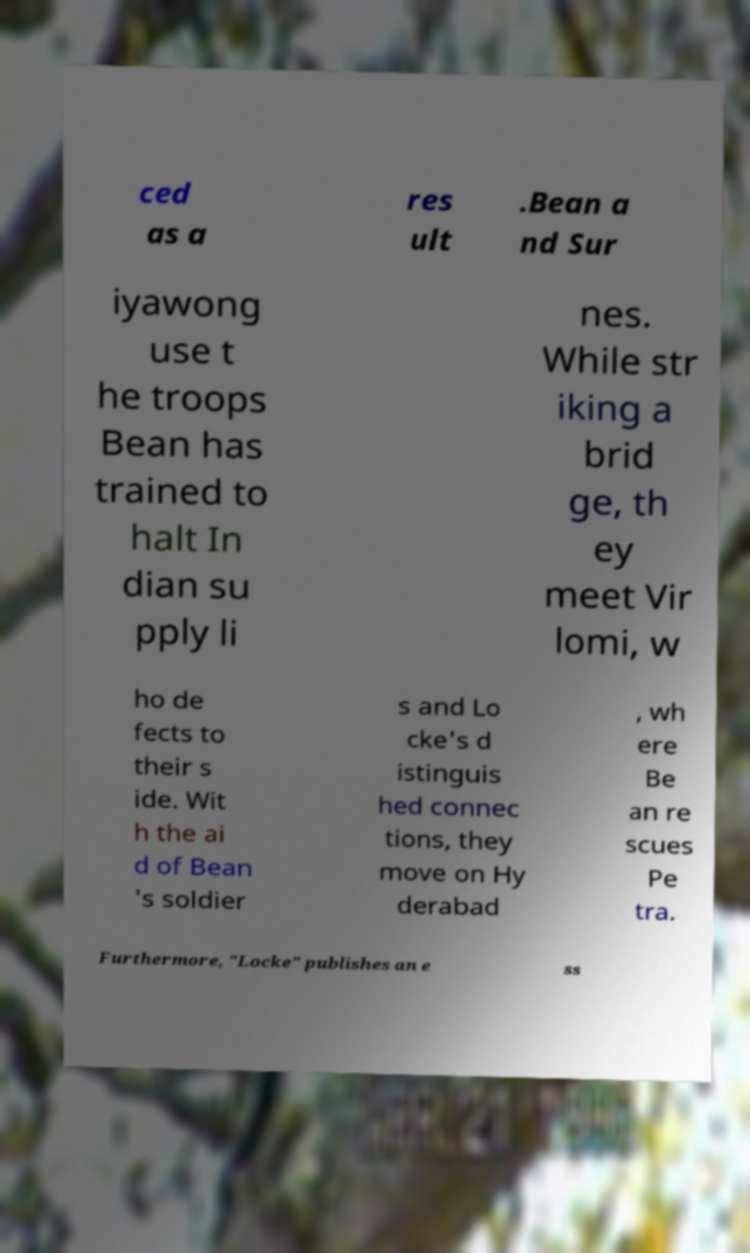Can you accurately transcribe the text from the provided image for me? ced as a res ult .Bean a nd Sur iyawong use t he troops Bean has trained to halt In dian su pply li nes. While str iking a brid ge, th ey meet Vir lomi, w ho de fects to their s ide. Wit h the ai d of Bean 's soldier s and Lo cke's d istinguis hed connec tions, they move on Hy derabad , wh ere Be an re scues Pe tra. Furthermore, "Locke" publishes an e ss 